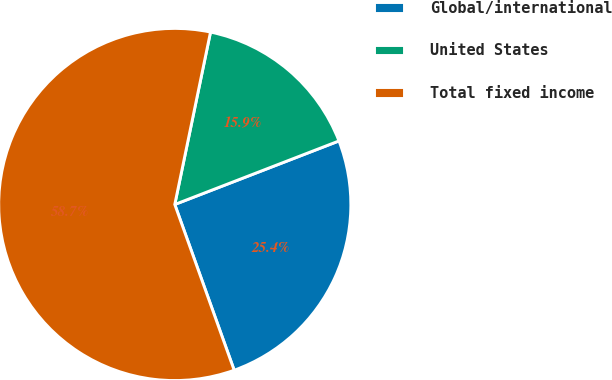Convert chart. <chart><loc_0><loc_0><loc_500><loc_500><pie_chart><fcel>Global/international<fcel>United States<fcel>Total fixed income<nl><fcel>25.4%<fcel>15.87%<fcel>58.73%<nl></chart> 